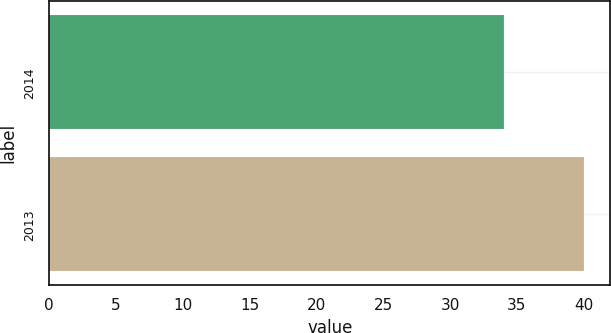Convert chart to OTSL. <chart><loc_0><loc_0><loc_500><loc_500><bar_chart><fcel>2014<fcel>2013<nl><fcel>34<fcel>40<nl></chart> 